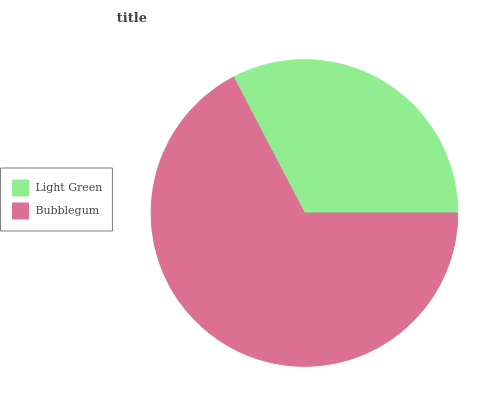Is Light Green the minimum?
Answer yes or no. Yes. Is Bubblegum the maximum?
Answer yes or no. Yes. Is Bubblegum the minimum?
Answer yes or no. No. Is Bubblegum greater than Light Green?
Answer yes or no. Yes. Is Light Green less than Bubblegum?
Answer yes or no. Yes. Is Light Green greater than Bubblegum?
Answer yes or no. No. Is Bubblegum less than Light Green?
Answer yes or no. No. Is Bubblegum the high median?
Answer yes or no. Yes. Is Light Green the low median?
Answer yes or no. Yes. Is Light Green the high median?
Answer yes or no. No. Is Bubblegum the low median?
Answer yes or no. No. 